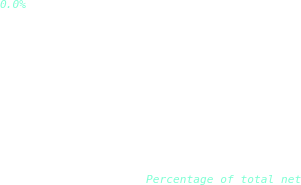<chart> <loc_0><loc_0><loc_500><loc_500><pie_chart><fcel>Sales and marketing<fcel>Percentage of total net<nl><fcel>100.0%<fcel>0.0%<nl></chart> 